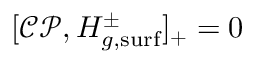Convert formula to latex. <formula><loc_0><loc_0><loc_500><loc_500>[ \mathcal { C P } , H _ { g , s u r f } ^ { \pm } ] _ { + } = 0</formula> 